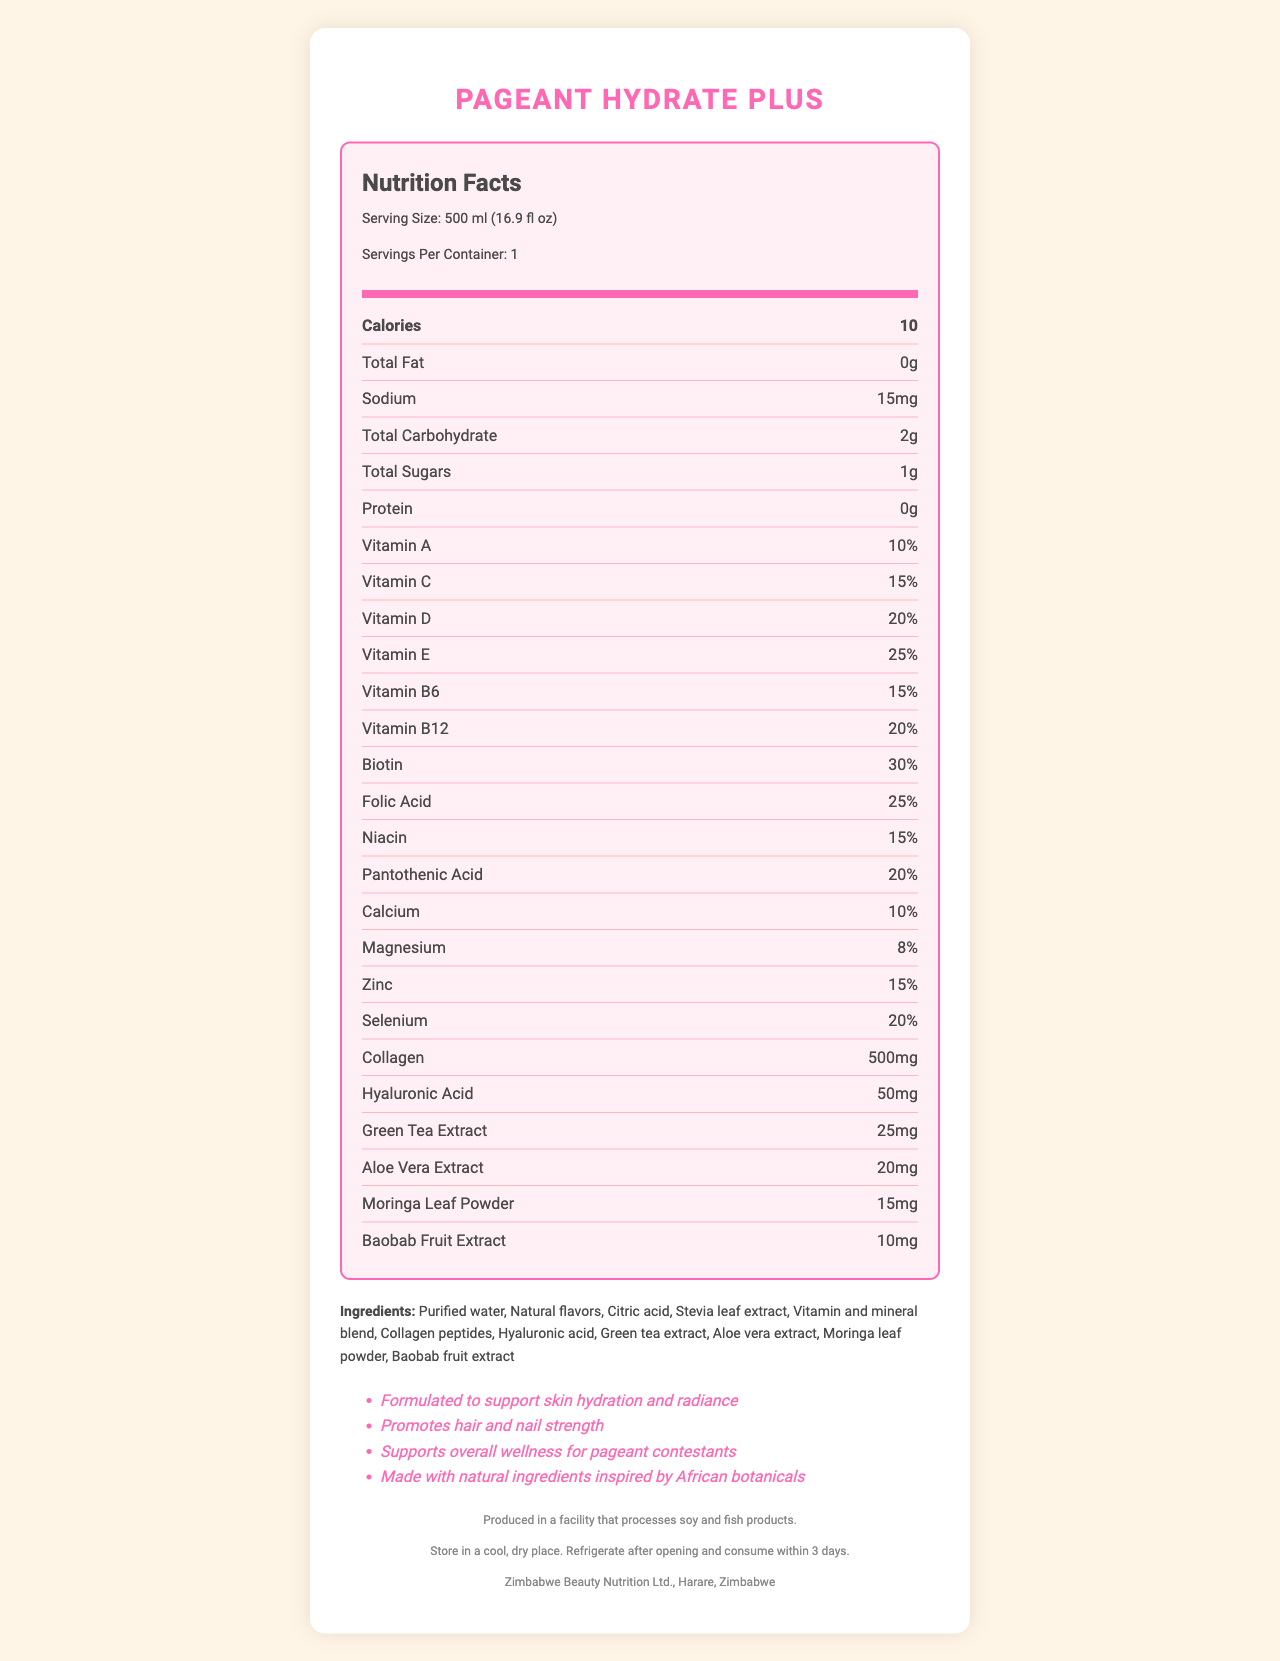what is the serving size of Pageant Hydrate Plus? The serving size is clearly stated in the document as "500 ml (16.9 fl oz)".
Answer: 500 ml (16.9 fl oz) how many calories are in one serving? The document indicates that one serving contains 10 calories.
Answer: 10 which vitamins have the highest percentage of daily value? According to the Nutrition Facts, Biotin has the highest percentage of daily value at 30%.
Answer: Biotin with 30% what is the sodium content in milligrams? The Nutrition Facts label lists the sodium content as 15mg.
Answer: 15mg how much collagen does Pageant Hydrate Plus contain per serving? The document lists 500mg of collagen per serving under the Nutrition Facts.
Answer: 500mg which ingredient is used as a sweetener in Pageant Hydrate Plus? The ingredient list includes Stevia leaf extract, which is commonly used as a sweetener.
Answer: Stevia leaf extract is Pageant Hydrate Plus suitable for someone with a soy allergy? The allergen information states that it is produced in a facility that processes soy, which could pose a risk for individuals with a soy allergy.
Answer: No where is the distributor of Pageant Hydrate Plus located? The document states that the distributor is Zimbabwe Beauty Nutrition Ltd., located in Harare, Zimbabwe.
Answer: Harare, Zimbabwe which of the following vitamins is NOT listed in the Nutrition Facts? 
A. Vitamin K 
B. Vitamin A 
C. Vitamin D 
D. Vitamin E The document lists vitamins A, D, and E, but Vitamin K is not mentioned.
Answer: A. Vitamin K what claims are made about the benefits of Pageant Hydrate Plus? 
A. Supports weight loss 
B. Promotes hair and nail strength 
C. Improves digestion 
D. Enhances mental focus The product claims include promoting hair and nail strength but do not mention supporting weight loss, improving digestion, or enhancing mental focus.
Answer: B. Promotes hair and nail strength is it necessary to refrigerate Pageant Hydrate Plus after opening? The storage instructions state that the product should be refrigerated after opening and consumed within 3 days.
Answer: Yes summarize the main idea of the document. The document provides detailed nutritional information, claims about the product's benefits, ingredient list, allergen information, and storage instructions for Pageant Hydrate Plus.
Answer: Pageant Hydrate Plus is a vitamin-enriched bottled water designed for beauty pageant contestants, highlighting skin hydration, hair and nail strength, and overall wellness. It contains various vitamins, minerals, collagen, and natural extracts, and is distributed by Zimbabwe Beauty Nutrition Ltd. what is the source of the natural flavors in Pageant Hydrate Plus? The document lists "Natural flavors" as an ingredient, but it does not provide specific details on the source.
Answer: Cannot be determined how much Baobab fruit extract is in each serving? The document specifies that there are 10mg of Baobab fruit extract in each serving.
Answer: 10mg which vitamin has the same daily value percentage as Pantothenic Acid? 
A. Vitamin B6 
B. Vitamin B12 
C. Vitamin C 
D. Niacin Both Vitamin B12 and Pantothenic Acid have a daily value percentage of 20%.
Answer: B. Vitamin B12 